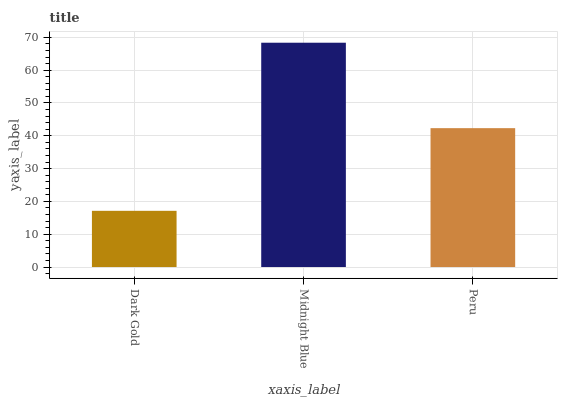Is Dark Gold the minimum?
Answer yes or no. Yes. Is Midnight Blue the maximum?
Answer yes or no. Yes. Is Peru the minimum?
Answer yes or no. No. Is Peru the maximum?
Answer yes or no. No. Is Midnight Blue greater than Peru?
Answer yes or no. Yes. Is Peru less than Midnight Blue?
Answer yes or no. Yes. Is Peru greater than Midnight Blue?
Answer yes or no. No. Is Midnight Blue less than Peru?
Answer yes or no. No. Is Peru the high median?
Answer yes or no. Yes. Is Peru the low median?
Answer yes or no. Yes. Is Dark Gold the high median?
Answer yes or no. No. Is Dark Gold the low median?
Answer yes or no. No. 